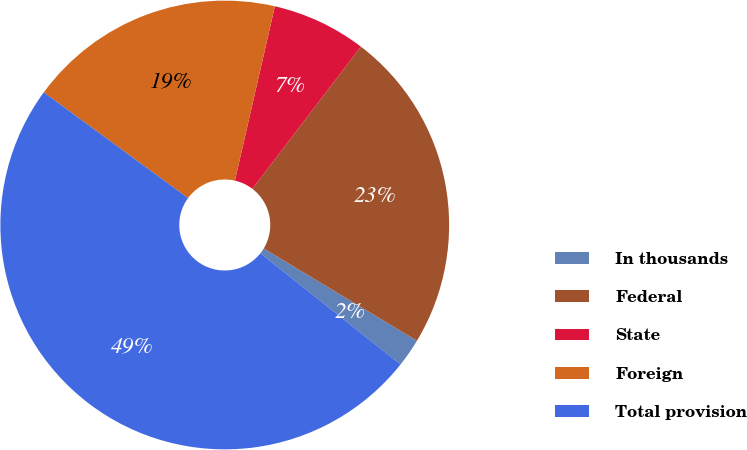<chart> <loc_0><loc_0><loc_500><loc_500><pie_chart><fcel>In thousands<fcel>Federal<fcel>State<fcel>Foreign<fcel>Total provision<nl><fcel>2.05%<fcel>23.25%<fcel>6.79%<fcel>18.52%<fcel>49.39%<nl></chart> 